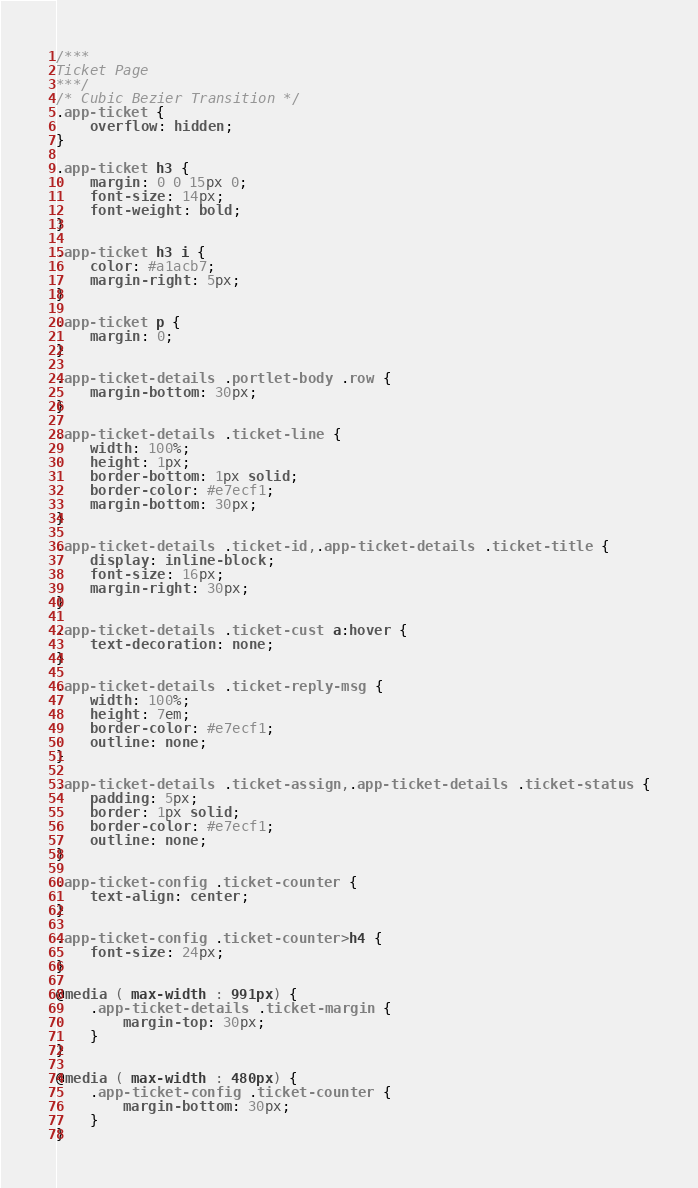<code> <loc_0><loc_0><loc_500><loc_500><_CSS_>/***
Ticket Page
***/
/* Cubic Bezier Transition */
.app-ticket {
	overflow: hidden;
}

.app-ticket h3 {
	margin: 0 0 15px 0;
	font-size: 14px;
	font-weight: bold;
}

.app-ticket h3 i {
	color: #a1acb7;
	margin-right: 5px;
}

.app-ticket p {
	margin: 0;
}

.app-ticket-details .portlet-body .row {
	margin-bottom: 30px;
}

.app-ticket-details .ticket-line {
	width: 100%;
	height: 1px;
	border-bottom: 1px solid;
	border-color: #e7ecf1;
	margin-bottom: 30px;
}

.app-ticket-details .ticket-id,.app-ticket-details .ticket-title {
	display: inline-block;
	font-size: 16px;
	margin-right: 30px;
}

.app-ticket-details .ticket-cust a:hover {
	text-decoration: none;
}

.app-ticket-details .ticket-reply-msg {
	width: 100%;
	height: 7em;
	border-color: #e7ecf1;
	outline: none;
}

.app-ticket-details .ticket-assign,.app-ticket-details .ticket-status {
	padding: 5px;
	border: 1px solid;
	border-color: #e7ecf1;
	outline: none;
}

.app-ticket-config .ticket-counter {
	text-align: center;
}

.app-ticket-config .ticket-counter>h4 {
	font-size: 24px;
}

@media ( max-width : 991px) {
	.app-ticket-details .ticket-margin {
		margin-top: 30px;
	}
}

@media ( max-width : 480px) {
	.app-ticket-config .ticket-counter {
		margin-bottom: 30px;
	}
}</code> 